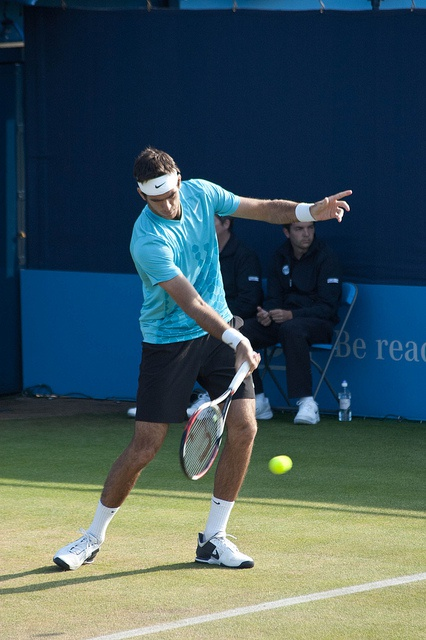Describe the objects in this image and their specific colors. I can see people in black, gray, teal, and white tones, people in black, gray, and navy tones, tennis racket in black, gray, darkgray, and white tones, people in black and gray tones, and chair in black, navy, and blue tones in this image. 